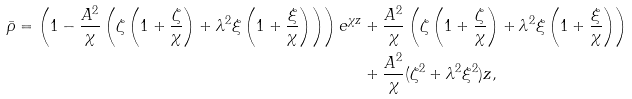Convert formula to latex. <formula><loc_0><loc_0><loc_500><loc_500>\bar { \rho } = \left ( 1 - \frac { A ^ { 2 } } { \chi } \left ( \zeta \left ( 1 + \frac { \zeta } { \chi } \right ) + \lambda ^ { 2 } \xi \left ( 1 + \frac { \xi } { \chi } \right ) \right ) \right ) e ^ { \chi z } & + \frac { A ^ { 2 } } { \chi } \left ( \zeta \left ( 1 + \frac { \zeta } { \chi } \right ) + \lambda ^ { 2 } \xi \left ( 1 + \frac { \xi } { \chi } \right ) \right ) \\ & + \frac { A ^ { 2 } } { \chi } ( \zeta ^ { 2 } + \lambda ^ { 2 } \xi ^ { 2 } ) z ,</formula> 